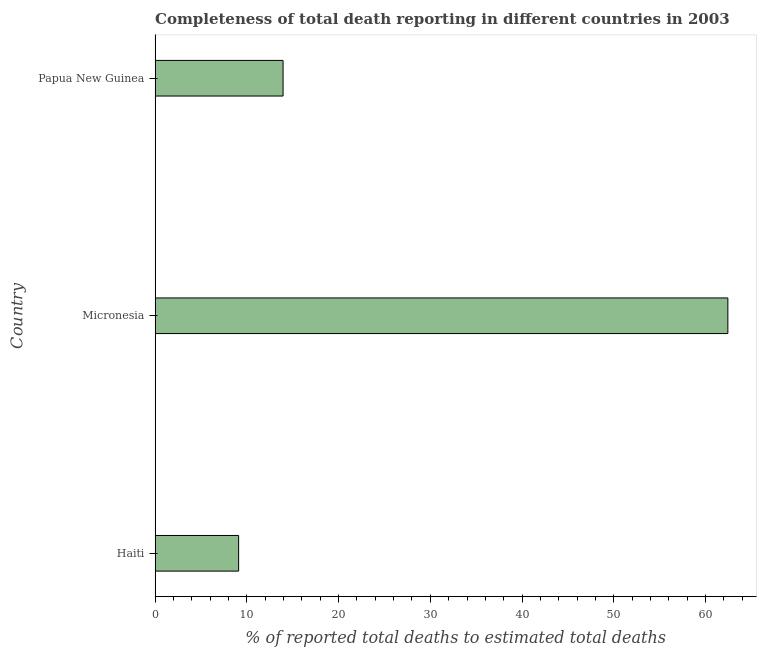Does the graph contain grids?
Ensure brevity in your answer.  No. What is the title of the graph?
Your response must be concise. Completeness of total death reporting in different countries in 2003. What is the label or title of the X-axis?
Make the answer very short. % of reported total deaths to estimated total deaths. What is the completeness of total death reports in Papua New Guinea?
Keep it short and to the point. 13.95. Across all countries, what is the maximum completeness of total death reports?
Provide a short and direct response. 62.43. Across all countries, what is the minimum completeness of total death reports?
Provide a short and direct response. 9.11. In which country was the completeness of total death reports maximum?
Provide a short and direct response. Micronesia. In which country was the completeness of total death reports minimum?
Provide a succinct answer. Haiti. What is the sum of the completeness of total death reports?
Offer a very short reply. 85.48. What is the difference between the completeness of total death reports in Haiti and Micronesia?
Your answer should be very brief. -53.32. What is the average completeness of total death reports per country?
Ensure brevity in your answer.  28.5. What is the median completeness of total death reports?
Make the answer very short. 13.95. What is the ratio of the completeness of total death reports in Haiti to that in Micronesia?
Provide a succinct answer. 0.15. Is the completeness of total death reports in Micronesia less than that in Papua New Guinea?
Your answer should be very brief. No. Is the difference between the completeness of total death reports in Haiti and Micronesia greater than the difference between any two countries?
Your answer should be compact. Yes. What is the difference between the highest and the second highest completeness of total death reports?
Give a very brief answer. 48.48. What is the difference between the highest and the lowest completeness of total death reports?
Ensure brevity in your answer.  53.32. What is the difference between two consecutive major ticks on the X-axis?
Your answer should be very brief. 10. Are the values on the major ticks of X-axis written in scientific E-notation?
Offer a terse response. No. What is the % of reported total deaths to estimated total deaths in Haiti?
Your answer should be very brief. 9.11. What is the % of reported total deaths to estimated total deaths of Micronesia?
Your answer should be compact. 62.43. What is the % of reported total deaths to estimated total deaths in Papua New Guinea?
Provide a succinct answer. 13.95. What is the difference between the % of reported total deaths to estimated total deaths in Haiti and Micronesia?
Make the answer very short. -53.32. What is the difference between the % of reported total deaths to estimated total deaths in Haiti and Papua New Guinea?
Provide a succinct answer. -4.84. What is the difference between the % of reported total deaths to estimated total deaths in Micronesia and Papua New Guinea?
Your answer should be compact. 48.48. What is the ratio of the % of reported total deaths to estimated total deaths in Haiti to that in Micronesia?
Offer a very short reply. 0.15. What is the ratio of the % of reported total deaths to estimated total deaths in Haiti to that in Papua New Guinea?
Offer a terse response. 0.65. What is the ratio of the % of reported total deaths to estimated total deaths in Micronesia to that in Papua New Guinea?
Keep it short and to the point. 4.47. 